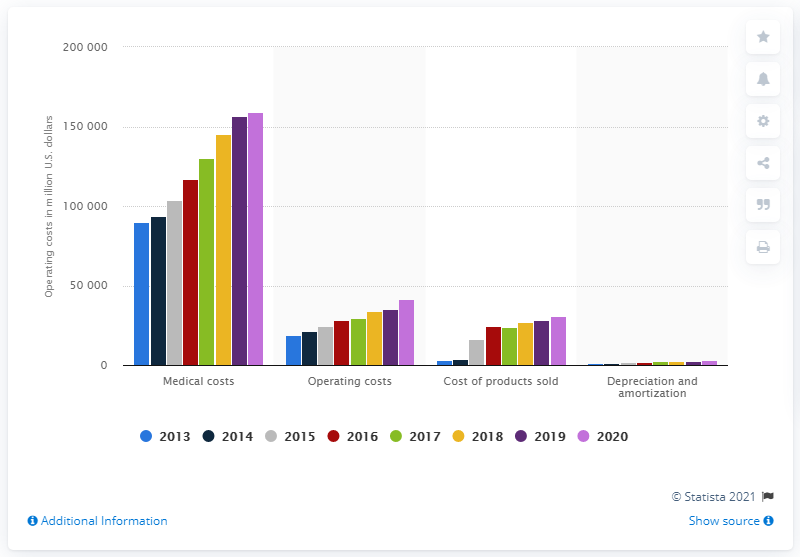Point out several critical features in this image. In 2020, the operating costs for medical expenses of UnitedHealth Group were approximately $159,396. 